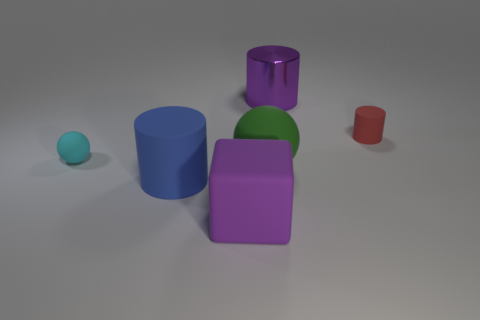Subtract all red cylinders. How many cylinders are left? 2 Add 4 tiny matte objects. How many objects exist? 10 Subtract all cubes. How many objects are left? 5 Subtract 2 spheres. How many spheres are left? 0 Subtract all big metal things. Subtract all large purple cylinders. How many objects are left? 4 Add 4 blue cylinders. How many blue cylinders are left? 5 Add 4 large cubes. How many large cubes exist? 5 Subtract all cyan balls. How many balls are left? 1 Subtract 1 purple blocks. How many objects are left? 5 Subtract all yellow cylinders. Subtract all cyan blocks. How many cylinders are left? 3 